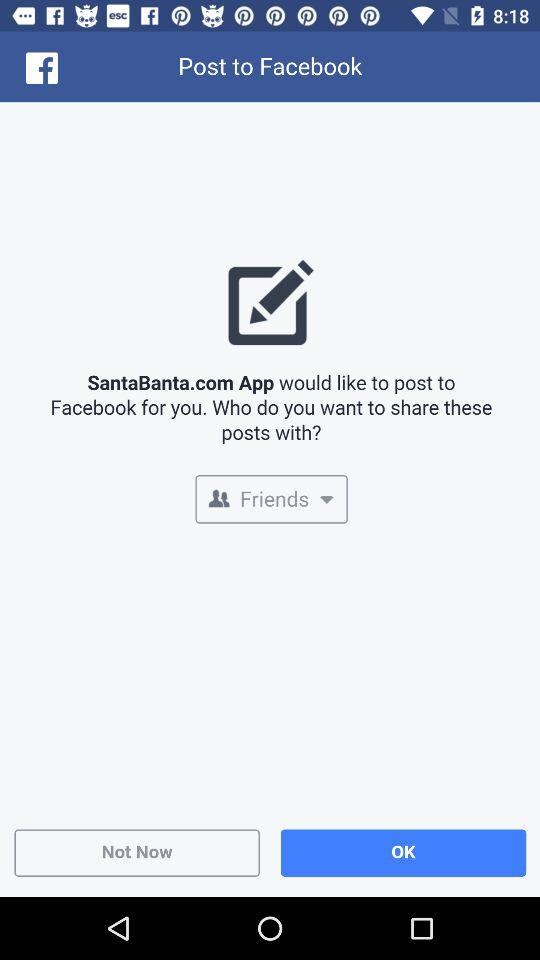What application is asking for permission? The application that is asking for permission is "SantaBanta.com App". 